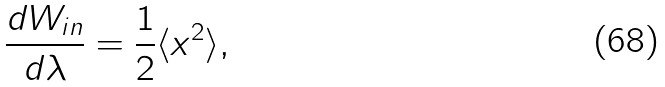<formula> <loc_0><loc_0><loc_500><loc_500>\frac { d { W } _ { i n } } { d \lambda } = \frac { 1 } { 2 } \langle x ^ { 2 } \rangle ,</formula> 